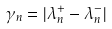<formula> <loc_0><loc_0><loc_500><loc_500>\gamma _ { n } = | \lambda _ { n } ^ { + } - \lambda _ { n } ^ { - } |</formula> 